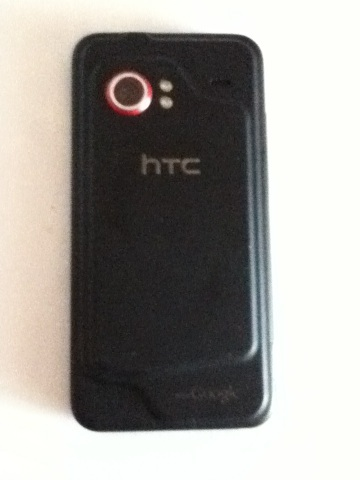What can you infer about the phone's age and operating system? Based on the design and branding, the phone in the image seems to be an older model, quite possibly from the early 2010s. During that time, HTC often equipped their phones with the Android operating system, which was complemented by the HTC Sense user interface for a more customized experience. The specific design and camera placement also suggest it may no longer be supported with the latest software updates, which typically span a few years post-release. 